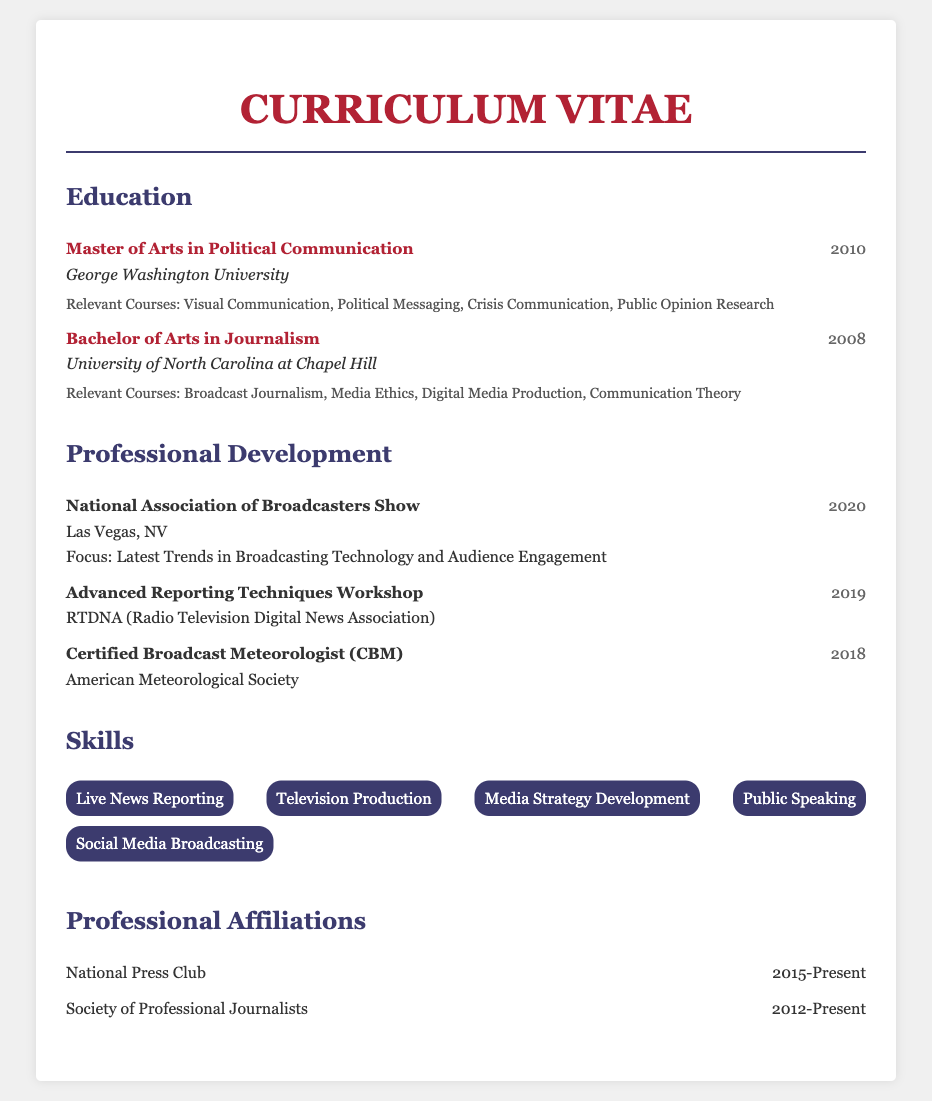what is the highest degree obtained? The highest degree listed in the education section is the Master of Arts in Political Communication.
Answer: Master of Arts in Political Communication which university awarded the Bachelor's degree? The institution that awarded the Bachelor's degree in Journalism is mentioned in the education section.
Answer: University of North Carolina at Chapel Hill what year was the Certified Broadcast Meteorologist attained? The year for this certification is found in the professional development section of the document.
Answer: 2018 how many professional affiliations are listed? The document lists a total of two professional affiliations, as indicated in the affiliations section.
Answer: 2 what was the focus of the 2020 National Association of Broadcasters Show? This information can be inferred from the focus stated in the professional development section.
Answer: Latest Trends in Broadcasting Technology and Audience Engagement which course related to communication is included in the Master's program? The relevant courses section lists a few courses, and one course specifically relates to communication.
Answer: Crisis Communication what organization conducted the Advanced Reporting Techniques Workshop? The name of the organization is provided in the professional development section.
Answer: RTDNA what skill related to public interaction is listed? A specific skill that involves public interaction is mentioned in the skills section.
Answer: Public Speaking 